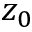Convert formula to latex. <formula><loc_0><loc_0><loc_500><loc_500>z _ { 0 }</formula> 